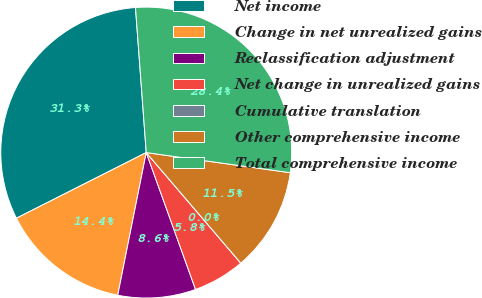<chart> <loc_0><loc_0><loc_500><loc_500><pie_chart><fcel>Net income<fcel>Change in net unrealized gains<fcel>Reclassification adjustment<fcel>Net change in unrealized gains<fcel>Cumulative translation<fcel>Other comprehensive income<fcel>Total comprehensive income<nl><fcel>31.27%<fcel>14.41%<fcel>8.64%<fcel>5.76%<fcel>0.0%<fcel>11.53%<fcel>28.39%<nl></chart> 